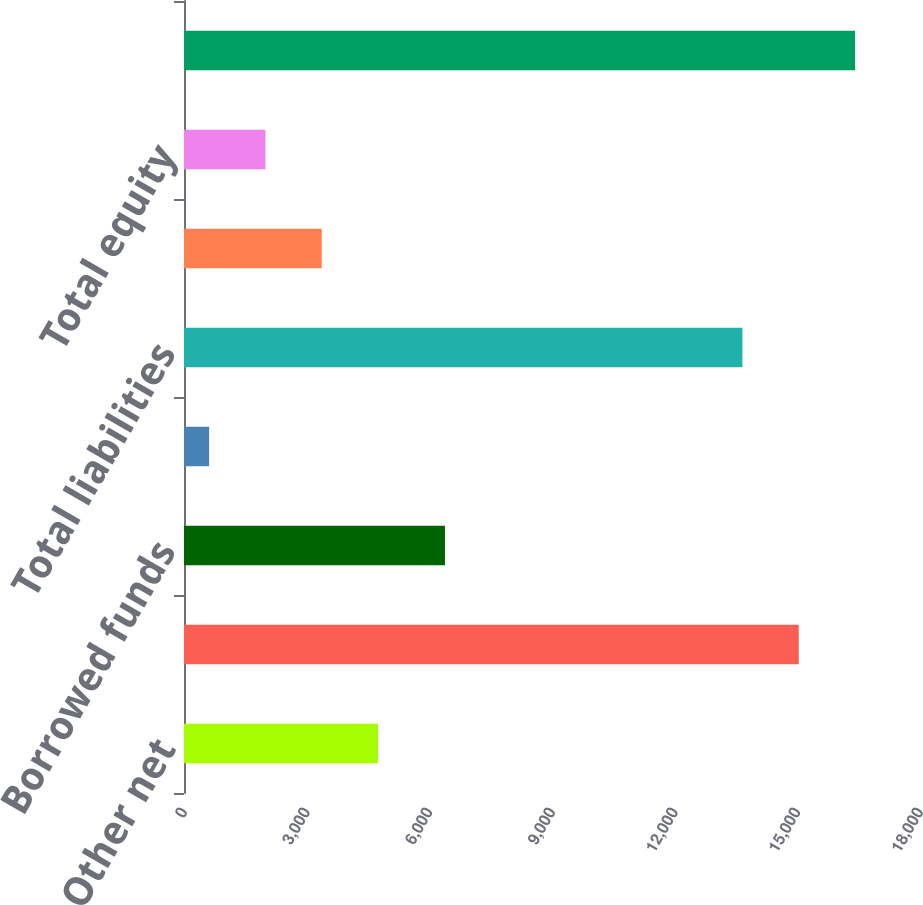<chart> <loc_0><loc_0><loc_500><loc_500><bar_chart><fcel>Other net<fcel>Total assets<fcel>Borrowed funds<fcel>Other<fcel>Total liabilities<fcel>Noncontrolling interests<fcel>Total equity<fcel>Total liabilities and equity<nl><fcel>4746.2<fcel>15034.4<fcel>6382<fcel>614<fcel>13657<fcel>3368.8<fcel>1991.4<fcel>16411.8<nl></chart> 